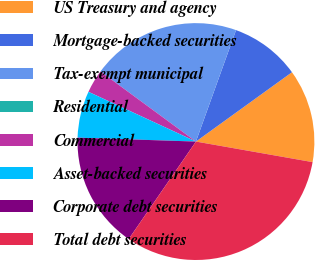<chart> <loc_0><loc_0><loc_500><loc_500><pie_chart><fcel>US Treasury and agency<fcel>Mortgage-backed securities<fcel>Tax-exempt municipal<fcel>Residential<fcel>Commercial<fcel>Asset-backed securities<fcel>Corporate debt securities<fcel>Total debt securities<nl><fcel>12.73%<fcel>9.55%<fcel>20.42%<fcel>0.0%<fcel>3.18%<fcel>6.37%<fcel>15.92%<fcel>31.83%<nl></chart> 